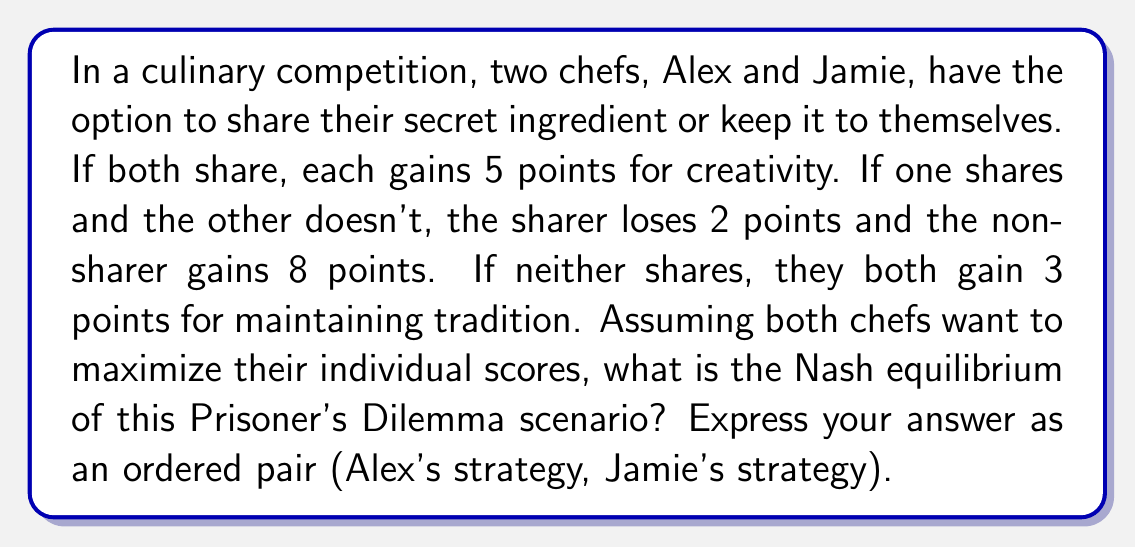Teach me how to tackle this problem. Let's approach this step-by-step using game theory:

1) First, let's create a payoff matrix for this scenario:

[asy]
unitsize(1cm);

draw((0,0)--(6,0)--(6,-6)--(0,-6)--cycle);
draw((0,-3)--(6,-3));
draw((3,0)--(3,-6));

label("Alex / Jamie", (1.5,-1.5), fontsize(8));
label("Share", (1.5,-4.5), fontsize(8));
label("Don't Share", (4.5,-4.5), fontsize(8));
label("Share", (4.5,-1.5), fontsize(8));
label("Don't Share", (1.5,-5.5), fontsize(8));

label("(5, 5)", (1.5,-3.75), fontsize(8));
label("(-2, 8)", (4.5,-3.75), fontsize(8));
label("(8, -2)", (1.5,-5.25), fontsize(8));
label("(3, 3)", (4.5,-5.25), fontsize(8));
[/asy]

2) In a Nash equilibrium, neither player can unilaterally change their strategy to increase their payoff.

3) Let's analyze each chef's best response to the other's strategies:

   For Alex:
   - If Jamie shares, Alex is better off not sharing (8 > 5)
   - If Jamie doesn't share, Alex is better off not sharing (3 > -2)

   For Jamie:
   - If Alex shares, Jamie is better off not sharing (8 > 5)
   - If Alex doesn't share, Jamie is better off not sharing (3 > -2)

4) We can see that regardless of what the other chef does, each chef's best strategy is to not share.

5) Therefore, the Nash equilibrium is (Don't Share, Don't Share).

This is a classic example of the Prisoner's Dilemma, where the Nash equilibrium is not the optimal outcome for both players. If both chefs cooperated and shared, they would each get 5 points instead of 3.
Answer: (Don't Share, Don't Share) 